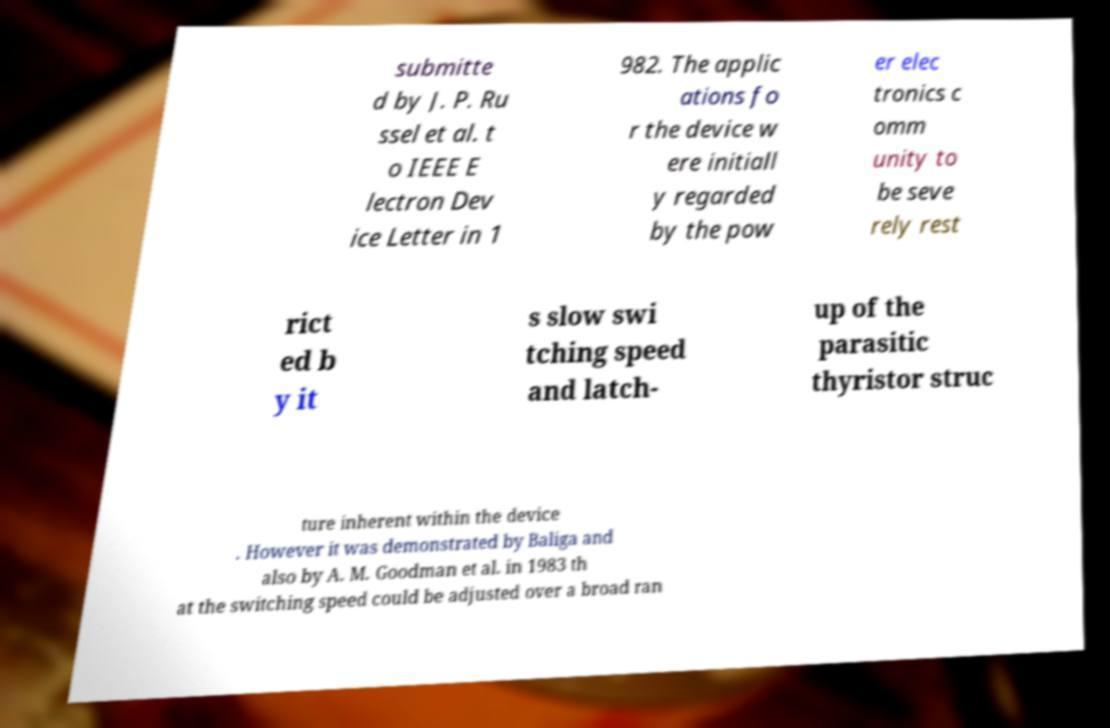Could you extract and type out the text from this image? submitte d by J. P. Ru ssel et al. t o IEEE E lectron Dev ice Letter in 1 982. The applic ations fo r the device w ere initiall y regarded by the pow er elec tronics c omm unity to be seve rely rest rict ed b y it s slow swi tching speed and latch- up of the parasitic thyristor struc ture inherent within the device . However it was demonstrated by Baliga and also by A. M. Goodman et al. in 1983 th at the switching speed could be adjusted over a broad ran 